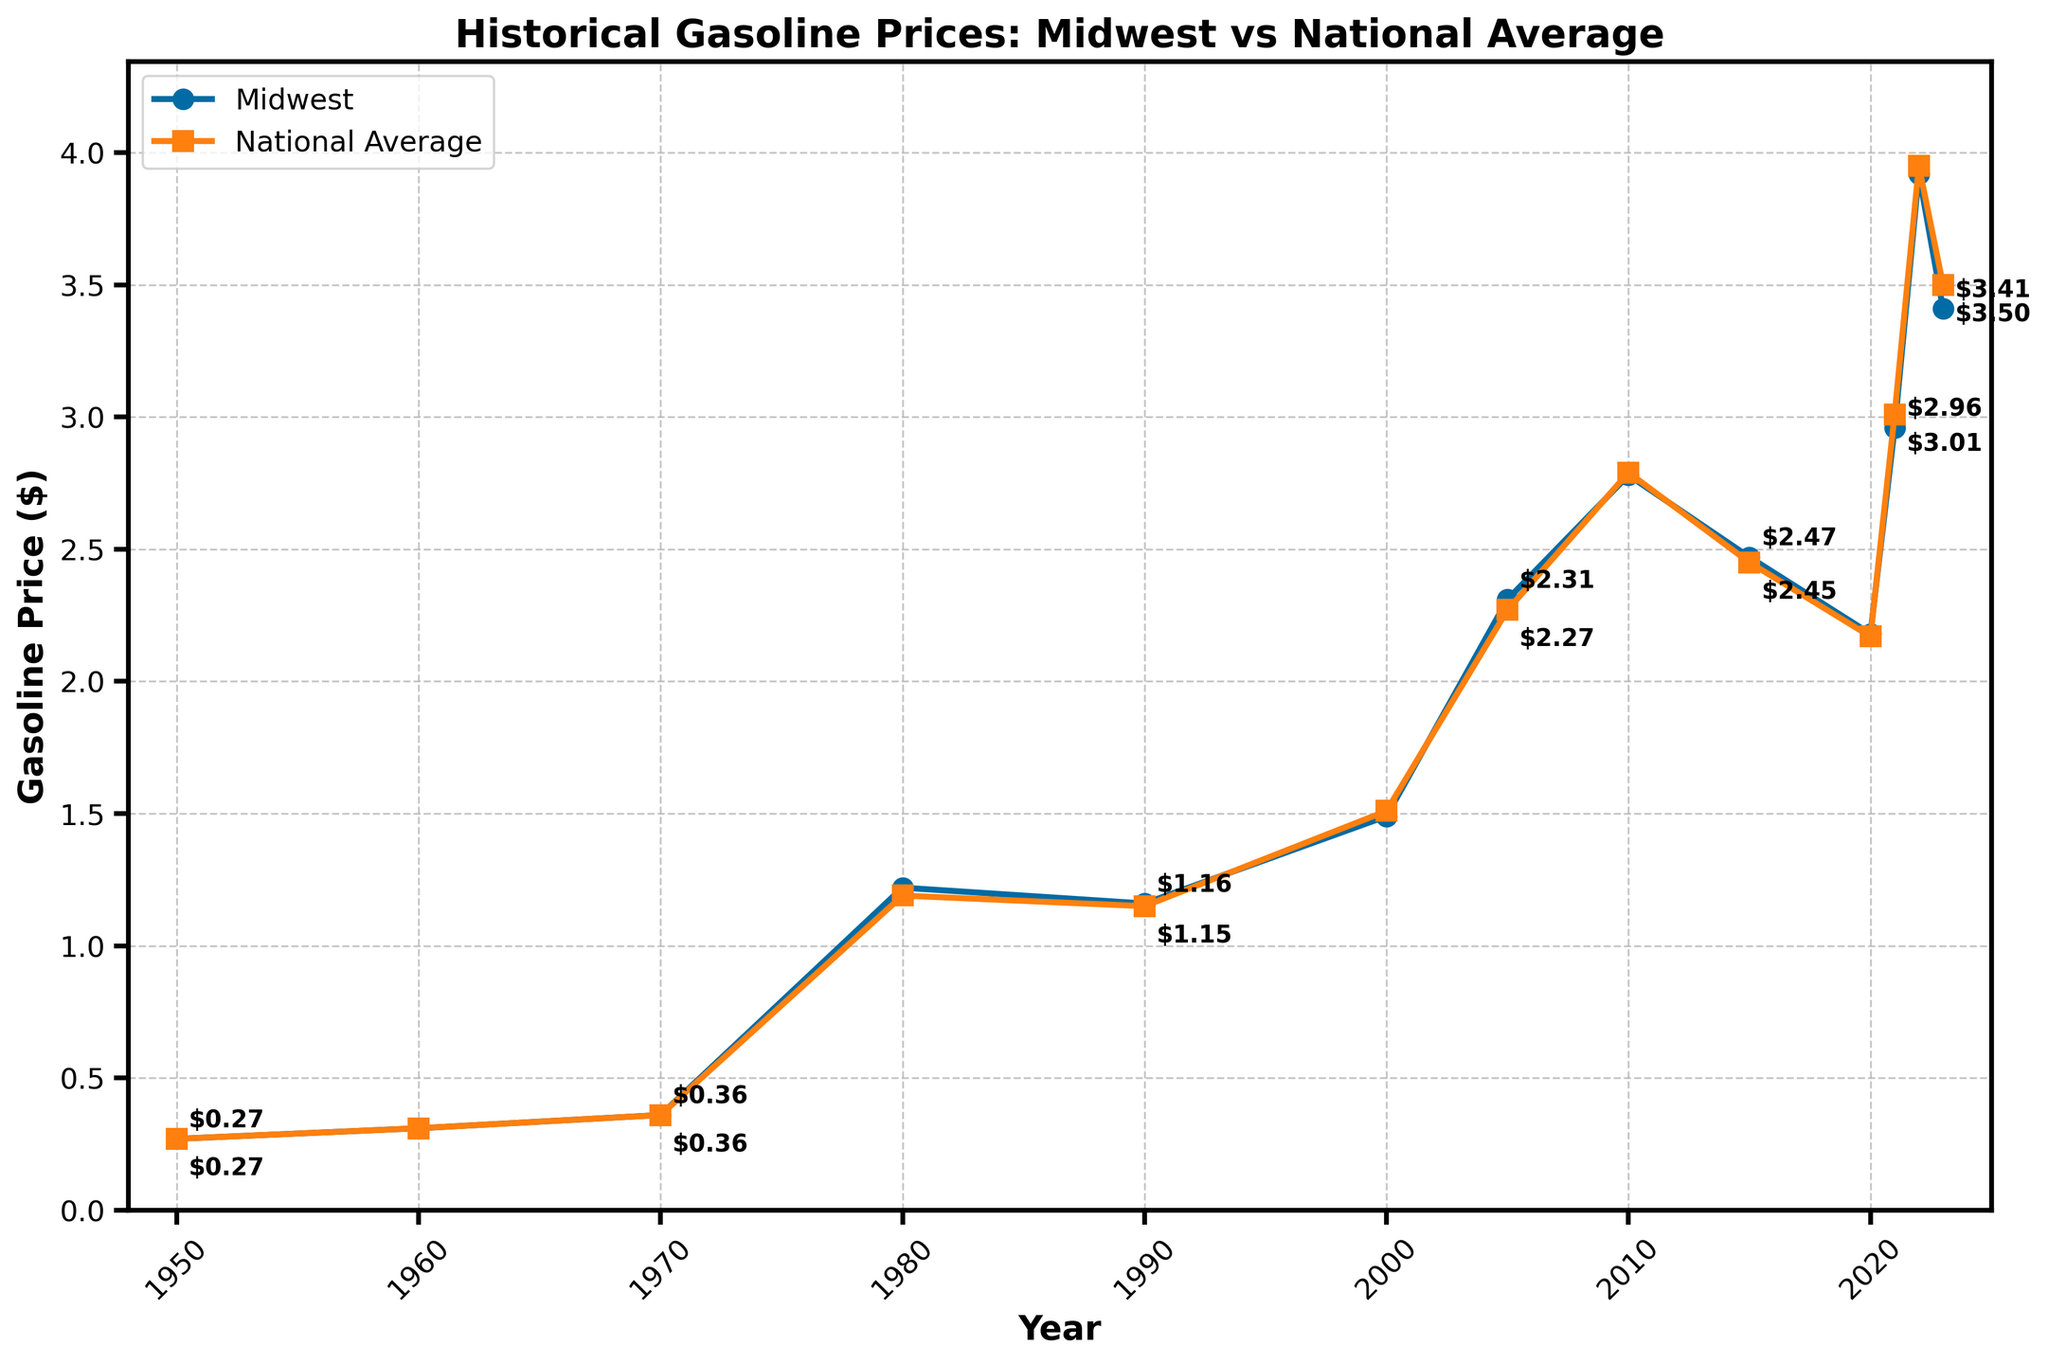how much did the Midwest gasoline price increase from 1980 to 2023? To find the increase, subtract the 1980 price from the 2023 price. The 1980 price is 1.22, and the 2023 price is 3.41. So, 3.41 - 1.22 = 2.19.
Answer: 2.19 In which year was the Midwest gasoline price equal to the national average gasoline price? By examining the figure, you'll see that the prices are equal in the years 1950, 1960, and 1970.
Answer: 1950, 1960, 1970 During which year did the national average gasoline price surpass the Midwest price for the first time? By scanning the lines in the figure, observe that in 2000 the national average (1.51) is slightly higher than the Midwest price (1.49). This is the first instance.
Answer: 2000 What was the highest gasoline price recorded in the Midwest, and in which year did it occur? Look for the peak value on the Midwest line. The highest price is 3.92 in the year 2022.
Answer: 3.92, 2022 Was there any year when the Midwest gasoline price was higher than the national average by more than $0.05? Compare the Midwest and national prices visually and look for the largest difference. In most years, prices differ by only a few cents, but in 2023, the difference is somewhat notable but not more than $0.05. Hence, none exceed this threshold.
Answer: No How does the trend of gasoline prices in the Midwest compare to the national trend from 1990 to 2010? From 1990 to 2010, both the Midwest and national prices show an overall increasing trend. The lines rise and fall similarly, indicating that Midwest and national prices follow the same general pattern within this period.
Answer: Similar trend In which decade did the Midwest gasoline price undergo the most significant relative increase? Check the slopes of the Midwest line in each decade. Between 1970 and 1980, the price jumps from 0.36 to 1.22, which’s comparatively much steeper than in other decades.
Answer: 1970s How do the gasoline prices in the Midwest compare to the national averages in the most recent year listed? In 2023, the Midwest price is 3.41, while the national average is 3.50.
Answer: Midwest is lower by 0.09 What is the average gasoline price in the Midwest over the years listed? Sum all the Midwest prices and divide by the number of years listed. (0.27 + 0.31 + 0.36 + 1.22 + 1.16 + 1.49 + 2.31 + 2.78 + 2.47 + 2.18 + 2.96 + 3.92 + 3.41) / 13 ≈ 2.03.
Answer: 2.03 